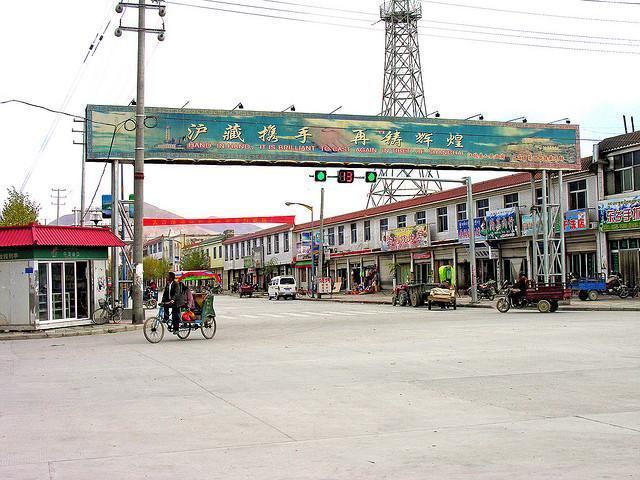How many cows are standing in the road?
Give a very brief answer. 0. 